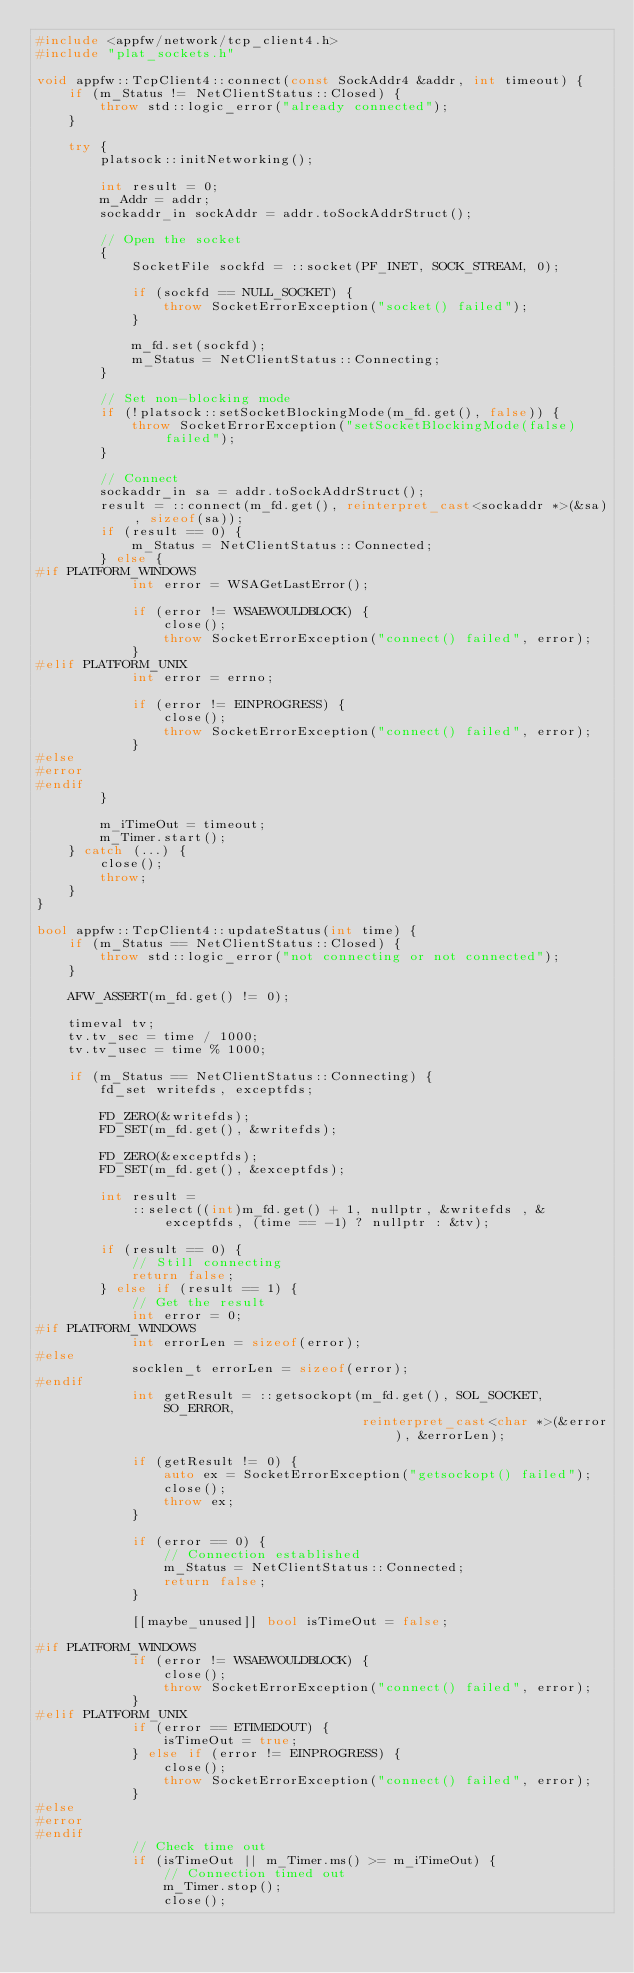<code> <loc_0><loc_0><loc_500><loc_500><_C++_>#include <appfw/network/tcp_client4.h>
#include "plat_sockets.h"

void appfw::TcpClient4::connect(const SockAddr4 &addr, int timeout) {
    if (m_Status != NetClientStatus::Closed) {
        throw std::logic_error("already connected");
    }

    try {
        platsock::initNetworking();

        int result = 0;
        m_Addr = addr;
        sockaddr_in sockAddr = addr.toSockAddrStruct();

        // Open the socket
        {
            SocketFile sockfd = ::socket(PF_INET, SOCK_STREAM, 0);

            if (sockfd == NULL_SOCKET) {
                throw SocketErrorException("socket() failed");
            }

            m_fd.set(sockfd);
            m_Status = NetClientStatus::Connecting;
        }

        // Set non-blocking mode
        if (!platsock::setSocketBlockingMode(m_fd.get(), false)) {
            throw SocketErrorException("setSocketBlockingMode(false) failed");
        }

        // Connect
        sockaddr_in sa = addr.toSockAddrStruct();
        result = ::connect(m_fd.get(), reinterpret_cast<sockaddr *>(&sa), sizeof(sa));
        if (result == 0) {
            m_Status = NetClientStatus::Connected;
        } else {
#if PLATFORM_WINDOWS
            int error = WSAGetLastError();

            if (error != WSAEWOULDBLOCK) {
                close();
                throw SocketErrorException("connect() failed", error);
            }
#elif PLATFORM_UNIX
            int error = errno;

            if (error != EINPROGRESS) {
                close();
                throw SocketErrorException("connect() failed", error);
            }
#else
#error
#endif
        }

        m_iTimeOut = timeout;
        m_Timer.start();
    } catch (...) {
        close();
        throw;
    }
}

bool appfw::TcpClient4::updateStatus(int time) {
    if (m_Status == NetClientStatus::Closed) {
        throw std::logic_error("not connecting or not connected");
    }

    AFW_ASSERT(m_fd.get() != 0);

    timeval tv;
    tv.tv_sec = time / 1000;
    tv.tv_usec = time % 1000;

    if (m_Status == NetClientStatus::Connecting) {
        fd_set writefds, exceptfds;

        FD_ZERO(&writefds);
        FD_SET(m_fd.get(), &writefds);

        FD_ZERO(&exceptfds);
        FD_SET(m_fd.get(), &exceptfds);

        int result =
            ::select((int)m_fd.get() + 1, nullptr, &writefds , & exceptfds, (time == -1) ? nullptr : &tv);

        if (result == 0) {
            // Still connecting
            return false;
        } else if (result == 1) {
            // Get the result
            int error = 0;
#if PLATFORM_WINDOWS
            int errorLen = sizeof(error);
#else
            socklen_t errorLen = sizeof(error);
#endif
            int getResult = ::getsockopt(m_fd.get(), SOL_SOCKET, SO_ERROR,
                                         reinterpret_cast<char *>(&error), &errorLen);

            if (getResult != 0) {
                auto ex = SocketErrorException("getsockopt() failed");
                close();
                throw ex;
            }

            if (error == 0) {
                // Connection established
                m_Status = NetClientStatus::Connected;
                return false;
            }

            [[maybe_unused]] bool isTimeOut = false;

#if PLATFORM_WINDOWS
            if (error != WSAEWOULDBLOCK) {
                close();
                throw SocketErrorException("connect() failed", error);
            }
#elif PLATFORM_UNIX
            if (error == ETIMEDOUT) {
                isTimeOut = true;
            } else if (error != EINPROGRESS) {
                close();
                throw SocketErrorException("connect() failed", error);
            }
#else
#error
#endif
            // Check time out
            if (isTimeOut || m_Timer.ms() >= m_iTimeOut) {
                // Connection timed out
                m_Timer.stop();
                close();</code> 